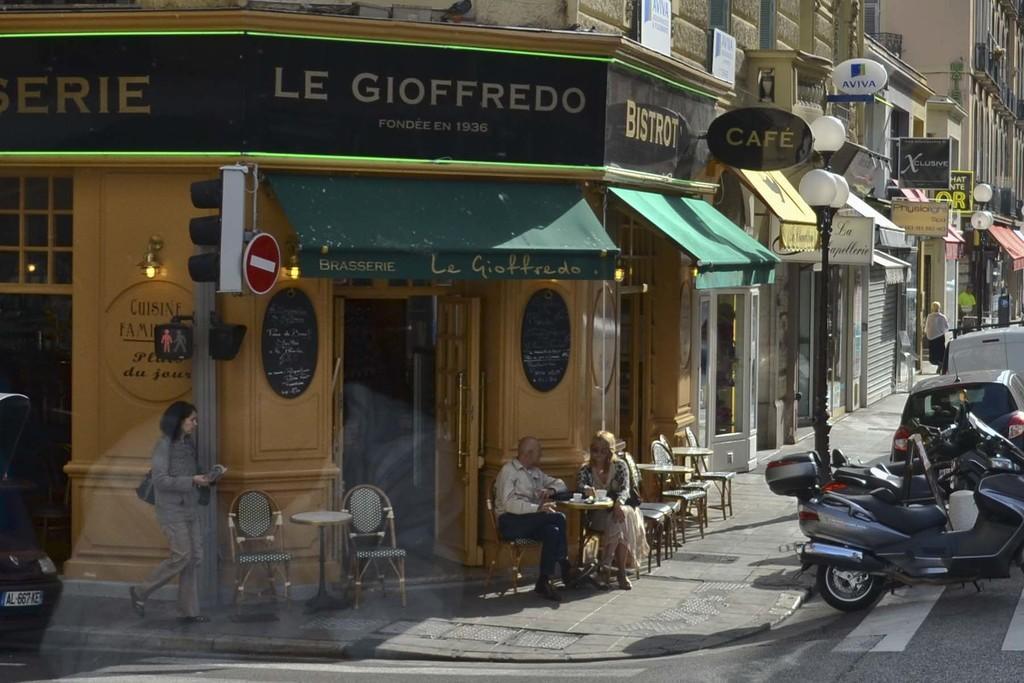Please provide a concise description of this image. In the foreground I can see two persons are sitting on the chairs in front of a table on which there are cups, vehicles on the road and a crowd. In the background I can see buildings, traffic signals and boards. This image is taken during a day. 